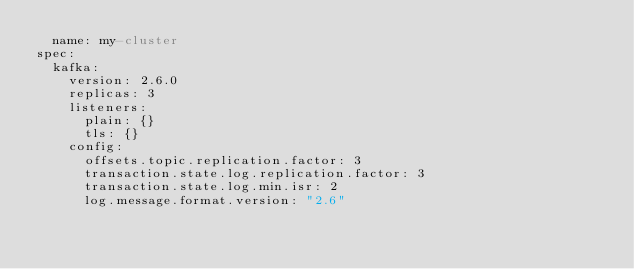Convert code to text. <code><loc_0><loc_0><loc_500><loc_500><_YAML_>  name: my-cluster
spec:
  kafka:
    version: 2.6.0
    replicas: 3
    listeners:
      plain: {}
      tls: {}
    config:
      offsets.topic.replication.factor: 3
      transaction.state.log.replication.factor: 3
      transaction.state.log.min.isr: 2
      log.message.format.version: "2.6"</code> 